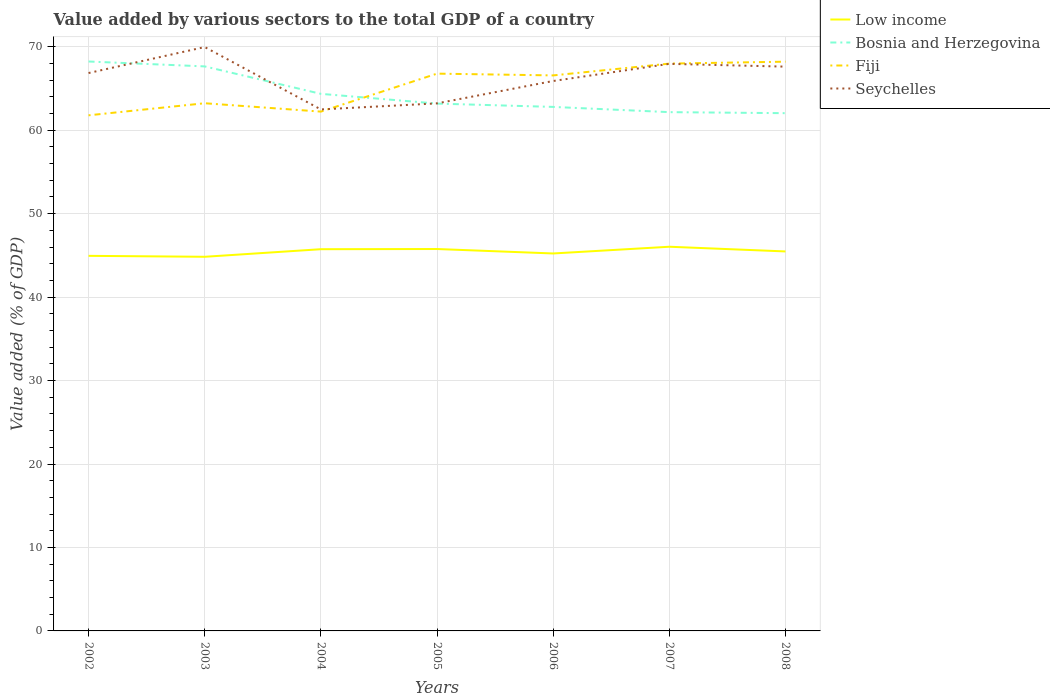How many different coloured lines are there?
Your answer should be very brief. 4. Is the number of lines equal to the number of legend labels?
Offer a very short reply. Yes. Across all years, what is the maximum value added by various sectors to the total GDP in Seychelles?
Make the answer very short. 62.49. In which year was the value added by various sectors to the total GDP in Fiji maximum?
Your answer should be very brief. 2002. What is the total value added by various sectors to the total GDP in Low income in the graph?
Ensure brevity in your answer.  0.53. What is the difference between the highest and the second highest value added by various sectors to the total GDP in Bosnia and Herzegovina?
Provide a succinct answer. 6.19. Is the value added by various sectors to the total GDP in Fiji strictly greater than the value added by various sectors to the total GDP in Low income over the years?
Provide a short and direct response. No. Does the graph contain any zero values?
Ensure brevity in your answer.  No. How many legend labels are there?
Your answer should be compact. 4. What is the title of the graph?
Your answer should be very brief. Value added by various sectors to the total GDP of a country. What is the label or title of the Y-axis?
Provide a succinct answer. Value added (% of GDP). What is the Value added (% of GDP) in Low income in 2002?
Give a very brief answer. 44.94. What is the Value added (% of GDP) in Bosnia and Herzegovina in 2002?
Your answer should be compact. 68.23. What is the Value added (% of GDP) in Fiji in 2002?
Your answer should be compact. 61.78. What is the Value added (% of GDP) in Seychelles in 2002?
Give a very brief answer. 66.85. What is the Value added (% of GDP) in Low income in 2003?
Your response must be concise. 44.83. What is the Value added (% of GDP) of Bosnia and Herzegovina in 2003?
Provide a short and direct response. 67.64. What is the Value added (% of GDP) of Fiji in 2003?
Offer a very short reply. 63.23. What is the Value added (% of GDP) of Seychelles in 2003?
Provide a succinct answer. 69.96. What is the Value added (% of GDP) in Low income in 2004?
Ensure brevity in your answer.  45.74. What is the Value added (% of GDP) of Bosnia and Herzegovina in 2004?
Ensure brevity in your answer.  64.35. What is the Value added (% of GDP) of Fiji in 2004?
Your answer should be compact. 62.23. What is the Value added (% of GDP) in Seychelles in 2004?
Offer a terse response. 62.49. What is the Value added (% of GDP) in Low income in 2005?
Offer a terse response. 45.76. What is the Value added (% of GDP) of Bosnia and Herzegovina in 2005?
Provide a succinct answer. 63.19. What is the Value added (% of GDP) of Fiji in 2005?
Offer a very short reply. 66.78. What is the Value added (% of GDP) in Seychelles in 2005?
Provide a short and direct response. 63.21. What is the Value added (% of GDP) of Low income in 2006?
Provide a succinct answer. 45.23. What is the Value added (% of GDP) of Bosnia and Herzegovina in 2006?
Make the answer very short. 62.79. What is the Value added (% of GDP) of Fiji in 2006?
Your answer should be very brief. 66.56. What is the Value added (% of GDP) in Seychelles in 2006?
Give a very brief answer. 65.89. What is the Value added (% of GDP) of Low income in 2007?
Offer a terse response. 46.03. What is the Value added (% of GDP) in Bosnia and Herzegovina in 2007?
Give a very brief answer. 62.16. What is the Value added (% of GDP) of Fiji in 2007?
Ensure brevity in your answer.  67.98. What is the Value added (% of GDP) in Seychelles in 2007?
Offer a terse response. 67.95. What is the Value added (% of GDP) of Low income in 2008?
Make the answer very short. 45.47. What is the Value added (% of GDP) of Bosnia and Herzegovina in 2008?
Keep it short and to the point. 62.04. What is the Value added (% of GDP) in Fiji in 2008?
Make the answer very short. 68.21. What is the Value added (% of GDP) in Seychelles in 2008?
Keep it short and to the point. 67.61. Across all years, what is the maximum Value added (% of GDP) in Low income?
Ensure brevity in your answer.  46.03. Across all years, what is the maximum Value added (% of GDP) in Bosnia and Herzegovina?
Your answer should be compact. 68.23. Across all years, what is the maximum Value added (% of GDP) in Fiji?
Your answer should be compact. 68.21. Across all years, what is the maximum Value added (% of GDP) of Seychelles?
Provide a succinct answer. 69.96. Across all years, what is the minimum Value added (% of GDP) in Low income?
Provide a succinct answer. 44.83. Across all years, what is the minimum Value added (% of GDP) in Bosnia and Herzegovina?
Offer a very short reply. 62.04. Across all years, what is the minimum Value added (% of GDP) in Fiji?
Offer a very short reply. 61.78. Across all years, what is the minimum Value added (% of GDP) of Seychelles?
Ensure brevity in your answer.  62.49. What is the total Value added (% of GDP) of Low income in the graph?
Your answer should be compact. 318. What is the total Value added (% of GDP) in Bosnia and Herzegovina in the graph?
Ensure brevity in your answer.  450.4. What is the total Value added (% of GDP) in Fiji in the graph?
Offer a very short reply. 456.76. What is the total Value added (% of GDP) in Seychelles in the graph?
Your response must be concise. 463.97. What is the difference between the Value added (% of GDP) in Low income in 2002 and that in 2003?
Offer a very short reply. 0.11. What is the difference between the Value added (% of GDP) in Bosnia and Herzegovina in 2002 and that in 2003?
Make the answer very short. 0.59. What is the difference between the Value added (% of GDP) in Fiji in 2002 and that in 2003?
Keep it short and to the point. -1.45. What is the difference between the Value added (% of GDP) in Seychelles in 2002 and that in 2003?
Offer a very short reply. -3.11. What is the difference between the Value added (% of GDP) in Low income in 2002 and that in 2004?
Provide a succinct answer. -0.8. What is the difference between the Value added (% of GDP) in Bosnia and Herzegovina in 2002 and that in 2004?
Provide a short and direct response. 3.88. What is the difference between the Value added (% of GDP) of Fiji in 2002 and that in 2004?
Your answer should be compact. -0.44. What is the difference between the Value added (% of GDP) in Seychelles in 2002 and that in 2004?
Give a very brief answer. 4.36. What is the difference between the Value added (% of GDP) in Low income in 2002 and that in 2005?
Provide a short and direct response. -0.82. What is the difference between the Value added (% of GDP) in Bosnia and Herzegovina in 2002 and that in 2005?
Provide a succinct answer. 5.04. What is the difference between the Value added (% of GDP) in Fiji in 2002 and that in 2005?
Your response must be concise. -4.99. What is the difference between the Value added (% of GDP) in Seychelles in 2002 and that in 2005?
Make the answer very short. 3.64. What is the difference between the Value added (% of GDP) in Low income in 2002 and that in 2006?
Your answer should be very brief. -0.29. What is the difference between the Value added (% of GDP) in Bosnia and Herzegovina in 2002 and that in 2006?
Give a very brief answer. 5.44. What is the difference between the Value added (% of GDP) of Fiji in 2002 and that in 2006?
Ensure brevity in your answer.  -4.78. What is the difference between the Value added (% of GDP) of Seychelles in 2002 and that in 2006?
Make the answer very short. 0.95. What is the difference between the Value added (% of GDP) of Low income in 2002 and that in 2007?
Your response must be concise. -1.09. What is the difference between the Value added (% of GDP) in Bosnia and Herzegovina in 2002 and that in 2007?
Provide a short and direct response. 6.07. What is the difference between the Value added (% of GDP) in Fiji in 2002 and that in 2007?
Ensure brevity in your answer.  -6.19. What is the difference between the Value added (% of GDP) of Seychelles in 2002 and that in 2007?
Provide a succinct answer. -1.1. What is the difference between the Value added (% of GDP) of Low income in 2002 and that in 2008?
Make the answer very short. -0.53. What is the difference between the Value added (% of GDP) in Bosnia and Herzegovina in 2002 and that in 2008?
Your answer should be compact. 6.19. What is the difference between the Value added (% of GDP) of Fiji in 2002 and that in 2008?
Provide a succinct answer. -6.43. What is the difference between the Value added (% of GDP) of Seychelles in 2002 and that in 2008?
Make the answer very short. -0.77. What is the difference between the Value added (% of GDP) of Low income in 2003 and that in 2004?
Make the answer very short. -0.91. What is the difference between the Value added (% of GDP) in Bosnia and Herzegovina in 2003 and that in 2004?
Your response must be concise. 3.29. What is the difference between the Value added (% of GDP) in Seychelles in 2003 and that in 2004?
Give a very brief answer. 7.47. What is the difference between the Value added (% of GDP) in Low income in 2003 and that in 2005?
Provide a short and direct response. -0.93. What is the difference between the Value added (% of GDP) in Bosnia and Herzegovina in 2003 and that in 2005?
Ensure brevity in your answer.  4.46. What is the difference between the Value added (% of GDP) in Fiji in 2003 and that in 2005?
Give a very brief answer. -3.55. What is the difference between the Value added (% of GDP) in Seychelles in 2003 and that in 2005?
Keep it short and to the point. 6.75. What is the difference between the Value added (% of GDP) in Low income in 2003 and that in 2006?
Offer a terse response. -0.4. What is the difference between the Value added (% of GDP) of Bosnia and Herzegovina in 2003 and that in 2006?
Your answer should be very brief. 4.85. What is the difference between the Value added (% of GDP) in Fiji in 2003 and that in 2006?
Your response must be concise. -3.34. What is the difference between the Value added (% of GDP) in Seychelles in 2003 and that in 2006?
Offer a terse response. 4.07. What is the difference between the Value added (% of GDP) of Low income in 2003 and that in 2007?
Your answer should be very brief. -1.2. What is the difference between the Value added (% of GDP) of Bosnia and Herzegovina in 2003 and that in 2007?
Provide a succinct answer. 5.48. What is the difference between the Value added (% of GDP) in Fiji in 2003 and that in 2007?
Offer a terse response. -4.75. What is the difference between the Value added (% of GDP) of Seychelles in 2003 and that in 2007?
Provide a succinct answer. 2.01. What is the difference between the Value added (% of GDP) in Low income in 2003 and that in 2008?
Your answer should be compact. -0.64. What is the difference between the Value added (% of GDP) of Bosnia and Herzegovina in 2003 and that in 2008?
Ensure brevity in your answer.  5.6. What is the difference between the Value added (% of GDP) of Fiji in 2003 and that in 2008?
Your answer should be very brief. -4.98. What is the difference between the Value added (% of GDP) of Seychelles in 2003 and that in 2008?
Your answer should be very brief. 2.35. What is the difference between the Value added (% of GDP) of Low income in 2004 and that in 2005?
Offer a terse response. -0.02. What is the difference between the Value added (% of GDP) in Bosnia and Herzegovina in 2004 and that in 2005?
Your response must be concise. 1.17. What is the difference between the Value added (% of GDP) of Fiji in 2004 and that in 2005?
Your response must be concise. -4.55. What is the difference between the Value added (% of GDP) of Seychelles in 2004 and that in 2005?
Make the answer very short. -0.73. What is the difference between the Value added (% of GDP) of Low income in 2004 and that in 2006?
Your answer should be compact. 0.51. What is the difference between the Value added (% of GDP) in Bosnia and Herzegovina in 2004 and that in 2006?
Keep it short and to the point. 1.57. What is the difference between the Value added (% of GDP) of Fiji in 2004 and that in 2006?
Provide a short and direct response. -4.34. What is the difference between the Value added (% of GDP) of Seychelles in 2004 and that in 2006?
Provide a short and direct response. -3.41. What is the difference between the Value added (% of GDP) of Low income in 2004 and that in 2007?
Your answer should be very brief. -0.3. What is the difference between the Value added (% of GDP) in Bosnia and Herzegovina in 2004 and that in 2007?
Provide a succinct answer. 2.19. What is the difference between the Value added (% of GDP) in Fiji in 2004 and that in 2007?
Provide a succinct answer. -5.75. What is the difference between the Value added (% of GDP) of Seychelles in 2004 and that in 2007?
Provide a succinct answer. -5.46. What is the difference between the Value added (% of GDP) in Low income in 2004 and that in 2008?
Provide a short and direct response. 0.27. What is the difference between the Value added (% of GDP) of Bosnia and Herzegovina in 2004 and that in 2008?
Your answer should be compact. 2.32. What is the difference between the Value added (% of GDP) in Fiji in 2004 and that in 2008?
Provide a succinct answer. -5.98. What is the difference between the Value added (% of GDP) in Seychelles in 2004 and that in 2008?
Offer a terse response. -5.13. What is the difference between the Value added (% of GDP) in Low income in 2005 and that in 2006?
Your answer should be compact. 0.53. What is the difference between the Value added (% of GDP) in Bosnia and Herzegovina in 2005 and that in 2006?
Offer a very short reply. 0.4. What is the difference between the Value added (% of GDP) of Fiji in 2005 and that in 2006?
Ensure brevity in your answer.  0.21. What is the difference between the Value added (% of GDP) in Seychelles in 2005 and that in 2006?
Provide a short and direct response. -2.68. What is the difference between the Value added (% of GDP) in Low income in 2005 and that in 2007?
Offer a terse response. -0.27. What is the difference between the Value added (% of GDP) of Bosnia and Herzegovina in 2005 and that in 2007?
Give a very brief answer. 1.02. What is the difference between the Value added (% of GDP) of Fiji in 2005 and that in 2007?
Your answer should be compact. -1.2. What is the difference between the Value added (% of GDP) in Seychelles in 2005 and that in 2007?
Your response must be concise. -4.74. What is the difference between the Value added (% of GDP) in Low income in 2005 and that in 2008?
Provide a short and direct response. 0.29. What is the difference between the Value added (% of GDP) in Bosnia and Herzegovina in 2005 and that in 2008?
Your answer should be very brief. 1.15. What is the difference between the Value added (% of GDP) of Fiji in 2005 and that in 2008?
Your answer should be compact. -1.43. What is the difference between the Value added (% of GDP) in Seychelles in 2005 and that in 2008?
Provide a short and direct response. -4.4. What is the difference between the Value added (% of GDP) of Low income in 2006 and that in 2007?
Offer a very short reply. -0.81. What is the difference between the Value added (% of GDP) in Bosnia and Herzegovina in 2006 and that in 2007?
Your response must be concise. 0.63. What is the difference between the Value added (% of GDP) of Fiji in 2006 and that in 2007?
Offer a very short reply. -1.41. What is the difference between the Value added (% of GDP) in Seychelles in 2006 and that in 2007?
Your answer should be very brief. -2.05. What is the difference between the Value added (% of GDP) in Low income in 2006 and that in 2008?
Your response must be concise. -0.24. What is the difference between the Value added (% of GDP) in Bosnia and Herzegovina in 2006 and that in 2008?
Make the answer very short. 0.75. What is the difference between the Value added (% of GDP) of Fiji in 2006 and that in 2008?
Give a very brief answer. -1.65. What is the difference between the Value added (% of GDP) in Seychelles in 2006 and that in 2008?
Provide a short and direct response. -1.72. What is the difference between the Value added (% of GDP) of Low income in 2007 and that in 2008?
Make the answer very short. 0.56. What is the difference between the Value added (% of GDP) of Bosnia and Herzegovina in 2007 and that in 2008?
Your answer should be compact. 0.12. What is the difference between the Value added (% of GDP) of Fiji in 2007 and that in 2008?
Your answer should be very brief. -0.23. What is the difference between the Value added (% of GDP) of Seychelles in 2007 and that in 2008?
Offer a terse response. 0.33. What is the difference between the Value added (% of GDP) of Low income in 2002 and the Value added (% of GDP) of Bosnia and Herzegovina in 2003?
Make the answer very short. -22.7. What is the difference between the Value added (% of GDP) in Low income in 2002 and the Value added (% of GDP) in Fiji in 2003?
Your answer should be very brief. -18.29. What is the difference between the Value added (% of GDP) of Low income in 2002 and the Value added (% of GDP) of Seychelles in 2003?
Your answer should be very brief. -25.02. What is the difference between the Value added (% of GDP) of Bosnia and Herzegovina in 2002 and the Value added (% of GDP) of Fiji in 2003?
Ensure brevity in your answer.  5. What is the difference between the Value added (% of GDP) of Bosnia and Herzegovina in 2002 and the Value added (% of GDP) of Seychelles in 2003?
Offer a very short reply. -1.73. What is the difference between the Value added (% of GDP) of Fiji in 2002 and the Value added (% of GDP) of Seychelles in 2003?
Keep it short and to the point. -8.18. What is the difference between the Value added (% of GDP) of Low income in 2002 and the Value added (% of GDP) of Bosnia and Herzegovina in 2004?
Offer a terse response. -19.41. What is the difference between the Value added (% of GDP) in Low income in 2002 and the Value added (% of GDP) in Fiji in 2004?
Provide a short and direct response. -17.28. What is the difference between the Value added (% of GDP) in Low income in 2002 and the Value added (% of GDP) in Seychelles in 2004?
Your answer should be compact. -17.54. What is the difference between the Value added (% of GDP) of Bosnia and Herzegovina in 2002 and the Value added (% of GDP) of Fiji in 2004?
Provide a succinct answer. 6. What is the difference between the Value added (% of GDP) in Bosnia and Herzegovina in 2002 and the Value added (% of GDP) in Seychelles in 2004?
Provide a short and direct response. 5.74. What is the difference between the Value added (% of GDP) of Fiji in 2002 and the Value added (% of GDP) of Seychelles in 2004?
Offer a terse response. -0.71. What is the difference between the Value added (% of GDP) of Low income in 2002 and the Value added (% of GDP) of Bosnia and Herzegovina in 2005?
Your response must be concise. -18.24. What is the difference between the Value added (% of GDP) in Low income in 2002 and the Value added (% of GDP) in Fiji in 2005?
Keep it short and to the point. -21.83. What is the difference between the Value added (% of GDP) in Low income in 2002 and the Value added (% of GDP) in Seychelles in 2005?
Make the answer very short. -18.27. What is the difference between the Value added (% of GDP) in Bosnia and Herzegovina in 2002 and the Value added (% of GDP) in Fiji in 2005?
Provide a succinct answer. 1.45. What is the difference between the Value added (% of GDP) in Bosnia and Herzegovina in 2002 and the Value added (% of GDP) in Seychelles in 2005?
Offer a terse response. 5.02. What is the difference between the Value added (% of GDP) in Fiji in 2002 and the Value added (% of GDP) in Seychelles in 2005?
Keep it short and to the point. -1.43. What is the difference between the Value added (% of GDP) in Low income in 2002 and the Value added (% of GDP) in Bosnia and Herzegovina in 2006?
Offer a terse response. -17.85. What is the difference between the Value added (% of GDP) in Low income in 2002 and the Value added (% of GDP) in Fiji in 2006?
Provide a succinct answer. -21.62. What is the difference between the Value added (% of GDP) in Low income in 2002 and the Value added (% of GDP) in Seychelles in 2006?
Your answer should be compact. -20.95. What is the difference between the Value added (% of GDP) of Bosnia and Herzegovina in 2002 and the Value added (% of GDP) of Fiji in 2006?
Your answer should be compact. 1.67. What is the difference between the Value added (% of GDP) in Bosnia and Herzegovina in 2002 and the Value added (% of GDP) in Seychelles in 2006?
Keep it short and to the point. 2.34. What is the difference between the Value added (% of GDP) in Fiji in 2002 and the Value added (% of GDP) in Seychelles in 2006?
Make the answer very short. -4.11. What is the difference between the Value added (% of GDP) of Low income in 2002 and the Value added (% of GDP) of Bosnia and Herzegovina in 2007?
Provide a succinct answer. -17.22. What is the difference between the Value added (% of GDP) of Low income in 2002 and the Value added (% of GDP) of Fiji in 2007?
Your response must be concise. -23.03. What is the difference between the Value added (% of GDP) of Low income in 2002 and the Value added (% of GDP) of Seychelles in 2007?
Your response must be concise. -23.01. What is the difference between the Value added (% of GDP) in Bosnia and Herzegovina in 2002 and the Value added (% of GDP) in Fiji in 2007?
Provide a short and direct response. 0.25. What is the difference between the Value added (% of GDP) in Bosnia and Herzegovina in 2002 and the Value added (% of GDP) in Seychelles in 2007?
Offer a very short reply. 0.28. What is the difference between the Value added (% of GDP) of Fiji in 2002 and the Value added (% of GDP) of Seychelles in 2007?
Your answer should be very brief. -6.17. What is the difference between the Value added (% of GDP) in Low income in 2002 and the Value added (% of GDP) in Bosnia and Herzegovina in 2008?
Your answer should be very brief. -17.1. What is the difference between the Value added (% of GDP) of Low income in 2002 and the Value added (% of GDP) of Fiji in 2008?
Provide a succinct answer. -23.27. What is the difference between the Value added (% of GDP) of Low income in 2002 and the Value added (% of GDP) of Seychelles in 2008?
Provide a short and direct response. -22.67. What is the difference between the Value added (% of GDP) of Bosnia and Herzegovina in 2002 and the Value added (% of GDP) of Fiji in 2008?
Offer a terse response. 0.02. What is the difference between the Value added (% of GDP) in Bosnia and Herzegovina in 2002 and the Value added (% of GDP) in Seychelles in 2008?
Ensure brevity in your answer.  0.62. What is the difference between the Value added (% of GDP) in Fiji in 2002 and the Value added (% of GDP) in Seychelles in 2008?
Give a very brief answer. -5.83. What is the difference between the Value added (% of GDP) of Low income in 2003 and the Value added (% of GDP) of Bosnia and Herzegovina in 2004?
Offer a very short reply. -19.52. What is the difference between the Value added (% of GDP) in Low income in 2003 and the Value added (% of GDP) in Fiji in 2004?
Offer a terse response. -17.39. What is the difference between the Value added (% of GDP) of Low income in 2003 and the Value added (% of GDP) of Seychelles in 2004?
Give a very brief answer. -17.66. What is the difference between the Value added (% of GDP) in Bosnia and Herzegovina in 2003 and the Value added (% of GDP) in Fiji in 2004?
Offer a very short reply. 5.42. What is the difference between the Value added (% of GDP) in Bosnia and Herzegovina in 2003 and the Value added (% of GDP) in Seychelles in 2004?
Provide a short and direct response. 5.16. What is the difference between the Value added (% of GDP) of Fiji in 2003 and the Value added (% of GDP) of Seychelles in 2004?
Your response must be concise. 0.74. What is the difference between the Value added (% of GDP) in Low income in 2003 and the Value added (% of GDP) in Bosnia and Herzegovina in 2005?
Make the answer very short. -18.36. What is the difference between the Value added (% of GDP) in Low income in 2003 and the Value added (% of GDP) in Fiji in 2005?
Provide a succinct answer. -21.95. What is the difference between the Value added (% of GDP) of Low income in 2003 and the Value added (% of GDP) of Seychelles in 2005?
Give a very brief answer. -18.38. What is the difference between the Value added (% of GDP) of Bosnia and Herzegovina in 2003 and the Value added (% of GDP) of Fiji in 2005?
Make the answer very short. 0.87. What is the difference between the Value added (% of GDP) of Bosnia and Herzegovina in 2003 and the Value added (% of GDP) of Seychelles in 2005?
Your answer should be very brief. 4.43. What is the difference between the Value added (% of GDP) in Fiji in 2003 and the Value added (% of GDP) in Seychelles in 2005?
Keep it short and to the point. 0.02. What is the difference between the Value added (% of GDP) in Low income in 2003 and the Value added (% of GDP) in Bosnia and Herzegovina in 2006?
Keep it short and to the point. -17.96. What is the difference between the Value added (% of GDP) in Low income in 2003 and the Value added (% of GDP) in Fiji in 2006?
Your response must be concise. -21.73. What is the difference between the Value added (% of GDP) in Low income in 2003 and the Value added (% of GDP) in Seychelles in 2006?
Make the answer very short. -21.06. What is the difference between the Value added (% of GDP) in Bosnia and Herzegovina in 2003 and the Value added (% of GDP) in Fiji in 2006?
Offer a terse response. 1.08. What is the difference between the Value added (% of GDP) in Bosnia and Herzegovina in 2003 and the Value added (% of GDP) in Seychelles in 2006?
Your response must be concise. 1.75. What is the difference between the Value added (% of GDP) in Fiji in 2003 and the Value added (% of GDP) in Seychelles in 2006?
Offer a terse response. -2.67. What is the difference between the Value added (% of GDP) in Low income in 2003 and the Value added (% of GDP) in Bosnia and Herzegovina in 2007?
Offer a terse response. -17.33. What is the difference between the Value added (% of GDP) in Low income in 2003 and the Value added (% of GDP) in Fiji in 2007?
Offer a very short reply. -23.15. What is the difference between the Value added (% of GDP) in Low income in 2003 and the Value added (% of GDP) in Seychelles in 2007?
Provide a succinct answer. -23.12. What is the difference between the Value added (% of GDP) of Bosnia and Herzegovina in 2003 and the Value added (% of GDP) of Fiji in 2007?
Offer a terse response. -0.33. What is the difference between the Value added (% of GDP) of Bosnia and Herzegovina in 2003 and the Value added (% of GDP) of Seychelles in 2007?
Give a very brief answer. -0.31. What is the difference between the Value added (% of GDP) in Fiji in 2003 and the Value added (% of GDP) in Seychelles in 2007?
Provide a succinct answer. -4.72. What is the difference between the Value added (% of GDP) in Low income in 2003 and the Value added (% of GDP) in Bosnia and Herzegovina in 2008?
Offer a very short reply. -17.21. What is the difference between the Value added (% of GDP) of Low income in 2003 and the Value added (% of GDP) of Fiji in 2008?
Keep it short and to the point. -23.38. What is the difference between the Value added (% of GDP) in Low income in 2003 and the Value added (% of GDP) in Seychelles in 2008?
Offer a very short reply. -22.78. What is the difference between the Value added (% of GDP) of Bosnia and Herzegovina in 2003 and the Value added (% of GDP) of Fiji in 2008?
Your answer should be very brief. -0.57. What is the difference between the Value added (% of GDP) in Bosnia and Herzegovina in 2003 and the Value added (% of GDP) in Seychelles in 2008?
Offer a terse response. 0.03. What is the difference between the Value added (% of GDP) in Fiji in 2003 and the Value added (% of GDP) in Seychelles in 2008?
Provide a succinct answer. -4.39. What is the difference between the Value added (% of GDP) of Low income in 2004 and the Value added (% of GDP) of Bosnia and Herzegovina in 2005?
Your answer should be compact. -17.45. What is the difference between the Value added (% of GDP) of Low income in 2004 and the Value added (% of GDP) of Fiji in 2005?
Give a very brief answer. -21.04. What is the difference between the Value added (% of GDP) in Low income in 2004 and the Value added (% of GDP) in Seychelles in 2005?
Ensure brevity in your answer.  -17.47. What is the difference between the Value added (% of GDP) of Bosnia and Herzegovina in 2004 and the Value added (% of GDP) of Fiji in 2005?
Ensure brevity in your answer.  -2.42. What is the difference between the Value added (% of GDP) of Bosnia and Herzegovina in 2004 and the Value added (% of GDP) of Seychelles in 2005?
Make the answer very short. 1.14. What is the difference between the Value added (% of GDP) in Fiji in 2004 and the Value added (% of GDP) in Seychelles in 2005?
Make the answer very short. -0.99. What is the difference between the Value added (% of GDP) in Low income in 2004 and the Value added (% of GDP) in Bosnia and Herzegovina in 2006?
Make the answer very short. -17.05. What is the difference between the Value added (% of GDP) of Low income in 2004 and the Value added (% of GDP) of Fiji in 2006?
Your response must be concise. -20.83. What is the difference between the Value added (% of GDP) in Low income in 2004 and the Value added (% of GDP) in Seychelles in 2006?
Offer a terse response. -20.16. What is the difference between the Value added (% of GDP) in Bosnia and Herzegovina in 2004 and the Value added (% of GDP) in Fiji in 2006?
Your answer should be very brief. -2.21. What is the difference between the Value added (% of GDP) in Bosnia and Herzegovina in 2004 and the Value added (% of GDP) in Seychelles in 2006?
Provide a succinct answer. -1.54. What is the difference between the Value added (% of GDP) of Fiji in 2004 and the Value added (% of GDP) of Seychelles in 2006?
Give a very brief answer. -3.67. What is the difference between the Value added (% of GDP) in Low income in 2004 and the Value added (% of GDP) in Bosnia and Herzegovina in 2007?
Provide a short and direct response. -16.42. What is the difference between the Value added (% of GDP) in Low income in 2004 and the Value added (% of GDP) in Fiji in 2007?
Provide a short and direct response. -22.24. What is the difference between the Value added (% of GDP) in Low income in 2004 and the Value added (% of GDP) in Seychelles in 2007?
Offer a terse response. -22.21. What is the difference between the Value added (% of GDP) in Bosnia and Herzegovina in 2004 and the Value added (% of GDP) in Fiji in 2007?
Provide a succinct answer. -3.62. What is the difference between the Value added (% of GDP) of Bosnia and Herzegovina in 2004 and the Value added (% of GDP) of Seychelles in 2007?
Your response must be concise. -3.59. What is the difference between the Value added (% of GDP) in Fiji in 2004 and the Value added (% of GDP) in Seychelles in 2007?
Give a very brief answer. -5.72. What is the difference between the Value added (% of GDP) in Low income in 2004 and the Value added (% of GDP) in Bosnia and Herzegovina in 2008?
Your answer should be very brief. -16.3. What is the difference between the Value added (% of GDP) in Low income in 2004 and the Value added (% of GDP) in Fiji in 2008?
Ensure brevity in your answer.  -22.47. What is the difference between the Value added (% of GDP) in Low income in 2004 and the Value added (% of GDP) in Seychelles in 2008?
Offer a terse response. -21.88. What is the difference between the Value added (% of GDP) in Bosnia and Herzegovina in 2004 and the Value added (% of GDP) in Fiji in 2008?
Provide a short and direct response. -3.85. What is the difference between the Value added (% of GDP) in Bosnia and Herzegovina in 2004 and the Value added (% of GDP) in Seychelles in 2008?
Your answer should be compact. -3.26. What is the difference between the Value added (% of GDP) in Fiji in 2004 and the Value added (% of GDP) in Seychelles in 2008?
Your answer should be compact. -5.39. What is the difference between the Value added (% of GDP) of Low income in 2005 and the Value added (% of GDP) of Bosnia and Herzegovina in 2006?
Provide a succinct answer. -17.03. What is the difference between the Value added (% of GDP) of Low income in 2005 and the Value added (% of GDP) of Fiji in 2006?
Keep it short and to the point. -20.8. What is the difference between the Value added (% of GDP) of Low income in 2005 and the Value added (% of GDP) of Seychelles in 2006?
Your response must be concise. -20.13. What is the difference between the Value added (% of GDP) in Bosnia and Herzegovina in 2005 and the Value added (% of GDP) in Fiji in 2006?
Ensure brevity in your answer.  -3.38. What is the difference between the Value added (% of GDP) of Bosnia and Herzegovina in 2005 and the Value added (% of GDP) of Seychelles in 2006?
Give a very brief answer. -2.71. What is the difference between the Value added (% of GDP) in Fiji in 2005 and the Value added (% of GDP) in Seychelles in 2006?
Keep it short and to the point. 0.88. What is the difference between the Value added (% of GDP) of Low income in 2005 and the Value added (% of GDP) of Bosnia and Herzegovina in 2007?
Your response must be concise. -16.4. What is the difference between the Value added (% of GDP) of Low income in 2005 and the Value added (% of GDP) of Fiji in 2007?
Your answer should be compact. -22.22. What is the difference between the Value added (% of GDP) in Low income in 2005 and the Value added (% of GDP) in Seychelles in 2007?
Give a very brief answer. -22.19. What is the difference between the Value added (% of GDP) in Bosnia and Herzegovina in 2005 and the Value added (% of GDP) in Fiji in 2007?
Keep it short and to the point. -4.79. What is the difference between the Value added (% of GDP) in Bosnia and Herzegovina in 2005 and the Value added (% of GDP) in Seychelles in 2007?
Your answer should be compact. -4.76. What is the difference between the Value added (% of GDP) of Fiji in 2005 and the Value added (% of GDP) of Seychelles in 2007?
Offer a terse response. -1.17. What is the difference between the Value added (% of GDP) of Low income in 2005 and the Value added (% of GDP) of Bosnia and Herzegovina in 2008?
Ensure brevity in your answer.  -16.28. What is the difference between the Value added (% of GDP) in Low income in 2005 and the Value added (% of GDP) in Fiji in 2008?
Keep it short and to the point. -22.45. What is the difference between the Value added (% of GDP) in Low income in 2005 and the Value added (% of GDP) in Seychelles in 2008?
Your answer should be very brief. -21.85. What is the difference between the Value added (% of GDP) of Bosnia and Herzegovina in 2005 and the Value added (% of GDP) of Fiji in 2008?
Provide a succinct answer. -5.02. What is the difference between the Value added (% of GDP) of Bosnia and Herzegovina in 2005 and the Value added (% of GDP) of Seychelles in 2008?
Make the answer very short. -4.43. What is the difference between the Value added (% of GDP) of Fiji in 2005 and the Value added (% of GDP) of Seychelles in 2008?
Your answer should be very brief. -0.84. What is the difference between the Value added (% of GDP) of Low income in 2006 and the Value added (% of GDP) of Bosnia and Herzegovina in 2007?
Keep it short and to the point. -16.93. What is the difference between the Value added (% of GDP) of Low income in 2006 and the Value added (% of GDP) of Fiji in 2007?
Your answer should be compact. -22.75. What is the difference between the Value added (% of GDP) of Low income in 2006 and the Value added (% of GDP) of Seychelles in 2007?
Offer a terse response. -22.72. What is the difference between the Value added (% of GDP) of Bosnia and Herzegovina in 2006 and the Value added (% of GDP) of Fiji in 2007?
Provide a short and direct response. -5.19. What is the difference between the Value added (% of GDP) in Bosnia and Herzegovina in 2006 and the Value added (% of GDP) in Seychelles in 2007?
Provide a short and direct response. -5.16. What is the difference between the Value added (% of GDP) in Fiji in 2006 and the Value added (% of GDP) in Seychelles in 2007?
Keep it short and to the point. -1.38. What is the difference between the Value added (% of GDP) of Low income in 2006 and the Value added (% of GDP) of Bosnia and Herzegovina in 2008?
Make the answer very short. -16.81. What is the difference between the Value added (% of GDP) in Low income in 2006 and the Value added (% of GDP) in Fiji in 2008?
Offer a very short reply. -22.98. What is the difference between the Value added (% of GDP) in Low income in 2006 and the Value added (% of GDP) in Seychelles in 2008?
Offer a terse response. -22.39. What is the difference between the Value added (% of GDP) of Bosnia and Herzegovina in 2006 and the Value added (% of GDP) of Fiji in 2008?
Make the answer very short. -5.42. What is the difference between the Value added (% of GDP) of Bosnia and Herzegovina in 2006 and the Value added (% of GDP) of Seychelles in 2008?
Ensure brevity in your answer.  -4.83. What is the difference between the Value added (% of GDP) of Fiji in 2006 and the Value added (% of GDP) of Seychelles in 2008?
Your response must be concise. -1.05. What is the difference between the Value added (% of GDP) of Low income in 2007 and the Value added (% of GDP) of Bosnia and Herzegovina in 2008?
Your answer should be compact. -16. What is the difference between the Value added (% of GDP) of Low income in 2007 and the Value added (% of GDP) of Fiji in 2008?
Provide a succinct answer. -22.18. What is the difference between the Value added (% of GDP) of Low income in 2007 and the Value added (% of GDP) of Seychelles in 2008?
Ensure brevity in your answer.  -21.58. What is the difference between the Value added (% of GDP) in Bosnia and Herzegovina in 2007 and the Value added (% of GDP) in Fiji in 2008?
Your response must be concise. -6.05. What is the difference between the Value added (% of GDP) of Bosnia and Herzegovina in 2007 and the Value added (% of GDP) of Seychelles in 2008?
Provide a succinct answer. -5.45. What is the difference between the Value added (% of GDP) of Fiji in 2007 and the Value added (% of GDP) of Seychelles in 2008?
Provide a succinct answer. 0.36. What is the average Value added (% of GDP) in Low income per year?
Your answer should be very brief. 45.43. What is the average Value added (% of GDP) in Bosnia and Herzegovina per year?
Provide a succinct answer. 64.34. What is the average Value added (% of GDP) of Fiji per year?
Offer a terse response. 65.25. What is the average Value added (% of GDP) of Seychelles per year?
Your response must be concise. 66.28. In the year 2002, what is the difference between the Value added (% of GDP) in Low income and Value added (% of GDP) in Bosnia and Herzegovina?
Your answer should be very brief. -23.29. In the year 2002, what is the difference between the Value added (% of GDP) of Low income and Value added (% of GDP) of Fiji?
Offer a very short reply. -16.84. In the year 2002, what is the difference between the Value added (% of GDP) in Low income and Value added (% of GDP) in Seychelles?
Your answer should be very brief. -21.91. In the year 2002, what is the difference between the Value added (% of GDP) in Bosnia and Herzegovina and Value added (% of GDP) in Fiji?
Offer a very short reply. 6.45. In the year 2002, what is the difference between the Value added (% of GDP) in Bosnia and Herzegovina and Value added (% of GDP) in Seychelles?
Make the answer very short. 1.38. In the year 2002, what is the difference between the Value added (% of GDP) in Fiji and Value added (% of GDP) in Seychelles?
Offer a very short reply. -5.07. In the year 2003, what is the difference between the Value added (% of GDP) in Low income and Value added (% of GDP) in Bosnia and Herzegovina?
Provide a short and direct response. -22.81. In the year 2003, what is the difference between the Value added (% of GDP) of Low income and Value added (% of GDP) of Fiji?
Your answer should be very brief. -18.4. In the year 2003, what is the difference between the Value added (% of GDP) of Low income and Value added (% of GDP) of Seychelles?
Give a very brief answer. -25.13. In the year 2003, what is the difference between the Value added (% of GDP) of Bosnia and Herzegovina and Value added (% of GDP) of Fiji?
Keep it short and to the point. 4.41. In the year 2003, what is the difference between the Value added (% of GDP) in Bosnia and Herzegovina and Value added (% of GDP) in Seychelles?
Offer a terse response. -2.32. In the year 2003, what is the difference between the Value added (% of GDP) of Fiji and Value added (% of GDP) of Seychelles?
Make the answer very short. -6.73. In the year 2004, what is the difference between the Value added (% of GDP) in Low income and Value added (% of GDP) in Bosnia and Herzegovina?
Offer a terse response. -18.62. In the year 2004, what is the difference between the Value added (% of GDP) of Low income and Value added (% of GDP) of Fiji?
Keep it short and to the point. -16.49. In the year 2004, what is the difference between the Value added (% of GDP) of Low income and Value added (% of GDP) of Seychelles?
Your answer should be very brief. -16.75. In the year 2004, what is the difference between the Value added (% of GDP) of Bosnia and Herzegovina and Value added (% of GDP) of Fiji?
Keep it short and to the point. 2.13. In the year 2004, what is the difference between the Value added (% of GDP) in Bosnia and Herzegovina and Value added (% of GDP) in Seychelles?
Your response must be concise. 1.87. In the year 2004, what is the difference between the Value added (% of GDP) of Fiji and Value added (% of GDP) of Seychelles?
Keep it short and to the point. -0.26. In the year 2005, what is the difference between the Value added (% of GDP) in Low income and Value added (% of GDP) in Bosnia and Herzegovina?
Offer a terse response. -17.43. In the year 2005, what is the difference between the Value added (% of GDP) in Low income and Value added (% of GDP) in Fiji?
Give a very brief answer. -21.02. In the year 2005, what is the difference between the Value added (% of GDP) of Low income and Value added (% of GDP) of Seychelles?
Your answer should be very brief. -17.45. In the year 2005, what is the difference between the Value added (% of GDP) of Bosnia and Herzegovina and Value added (% of GDP) of Fiji?
Your response must be concise. -3.59. In the year 2005, what is the difference between the Value added (% of GDP) in Bosnia and Herzegovina and Value added (% of GDP) in Seychelles?
Your response must be concise. -0.03. In the year 2005, what is the difference between the Value added (% of GDP) of Fiji and Value added (% of GDP) of Seychelles?
Keep it short and to the point. 3.56. In the year 2006, what is the difference between the Value added (% of GDP) in Low income and Value added (% of GDP) in Bosnia and Herzegovina?
Your answer should be compact. -17.56. In the year 2006, what is the difference between the Value added (% of GDP) in Low income and Value added (% of GDP) in Fiji?
Offer a very short reply. -21.34. In the year 2006, what is the difference between the Value added (% of GDP) in Low income and Value added (% of GDP) in Seychelles?
Keep it short and to the point. -20.67. In the year 2006, what is the difference between the Value added (% of GDP) of Bosnia and Herzegovina and Value added (% of GDP) of Fiji?
Your answer should be very brief. -3.78. In the year 2006, what is the difference between the Value added (% of GDP) in Bosnia and Herzegovina and Value added (% of GDP) in Seychelles?
Provide a short and direct response. -3.11. In the year 2006, what is the difference between the Value added (% of GDP) of Fiji and Value added (% of GDP) of Seychelles?
Provide a short and direct response. 0.67. In the year 2007, what is the difference between the Value added (% of GDP) in Low income and Value added (% of GDP) in Bosnia and Herzegovina?
Keep it short and to the point. -16.13. In the year 2007, what is the difference between the Value added (% of GDP) in Low income and Value added (% of GDP) in Fiji?
Your answer should be very brief. -21.94. In the year 2007, what is the difference between the Value added (% of GDP) in Low income and Value added (% of GDP) in Seychelles?
Make the answer very short. -21.91. In the year 2007, what is the difference between the Value added (% of GDP) of Bosnia and Herzegovina and Value added (% of GDP) of Fiji?
Make the answer very short. -5.81. In the year 2007, what is the difference between the Value added (% of GDP) in Bosnia and Herzegovina and Value added (% of GDP) in Seychelles?
Offer a terse response. -5.79. In the year 2007, what is the difference between the Value added (% of GDP) in Fiji and Value added (% of GDP) in Seychelles?
Offer a very short reply. 0.03. In the year 2008, what is the difference between the Value added (% of GDP) of Low income and Value added (% of GDP) of Bosnia and Herzegovina?
Your answer should be compact. -16.57. In the year 2008, what is the difference between the Value added (% of GDP) in Low income and Value added (% of GDP) in Fiji?
Provide a succinct answer. -22.74. In the year 2008, what is the difference between the Value added (% of GDP) of Low income and Value added (% of GDP) of Seychelles?
Your response must be concise. -22.14. In the year 2008, what is the difference between the Value added (% of GDP) of Bosnia and Herzegovina and Value added (% of GDP) of Fiji?
Offer a very short reply. -6.17. In the year 2008, what is the difference between the Value added (% of GDP) of Bosnia and Herzegovina and Value added (% of GDP) of Seychelles?
Your answer should be very brief. -5.58. In the year 2008, what is the difference between the Value added (% of GDP) in Fiji and Value added (% of GDP) in Seychelles?
Your answer should be compact. 0.59. What is the ratio of the Value added (% of GDP) in Low income in 2002 to that in 2003?
Ensure brevity in your answer.  1. What is the ratio of the Value added (% of GDP) in Bosnia and Herzegovina in 2002 to that in 2003?
Offer a terse response. 1.01. What is the ratio of the Value added (% of GDP) in Fiji in 2002 to that in 2003?
Ensure brevity in your answer.  0.98. What is the ratio of the Value added (% of GDP) of Seychelles in 2002 to that in 2003?
Your answer should be very brief. 0.96. What is the ratio of the Value added (% of GDP) of Low income in 2002 to that in 2004?
Offer a very short reply. 0.98. What is the ratio of the Value added (% of GDP) of Bosnia and Herzegovina in 2002 to that in 2004?
Keep it short and to the point. 1.06. What is the ratio of the Value added (% of GDP) of Seychelles in 2002 to that in 2004?
Ensure brevity in your answer.  1.07. What is the ratio of the Value added (% of GDP) in Low income in 2002 to that in 2005?
Offer a terse response. 0.98. What is the ratio of the Value added (% of GDP) in Bosnia and Herzegovina in 2002 to that in 2005?
Provide a succinct answer. 1.08. What is the ratio of the Value added (% of GDP) in Fiji in 2002 to that in 2005?
Your answer should be very brief. 0.93. What is the ratio of the Value added (% of GDP) in Seychelles in 2002 to that in 2005?
Your answer should be compact. 1.06. What is the ratio of the Value added (% of GDP) of Low income in 2002 to that in 2006?
Offer a terse response. 0.99. What is the ratio of the Value added (% of GDP) in Bosnia and Herzegovina in 2002 to that in 2006?
Offer a terse response. 1.09. What is the ratio of the Value added (% of GDP) in Fiji in 2002 to that in 2006?
Your response must be concise. 0.93. What is the ratio of the Value added (% of GDP) in Seychelles in 2002 to that in 2006?
Offer a terse response. 1.01. What is the ratio of the Value added (% of GDP) in Low income in 2002 to that in 2007?
Provide a succinct answer. 0.98. What is the ratio of the Value added (% of GDP) in Bosnia and Herzegovina in 2002 to that in 2007?
Provide a short and direct response. 1.1. What is the ratio of the Value added (% of GDP) in Fiji in 2002 to that in 2007?
Make the answer very short. 0.91. What is the ratio of the Value added (% of GDP) of Seychelles in 2002 to that in 2007?
Keep it short and to the point. 0.98. What is the ratio of the Value added (% of GDP) in Low income in 2002 to that in 2008?
Provide a short and direct response. 0.99. What is the ratio of the Value added (% of GDP) in Bosnia and Herzegovina in 2002 to that in 2008?
Offer a very short reply. 1.1. What is the ratio of the Value added (% of GDP) in Fiji in 2002 to that in 2008?
Keep it short and to the point. 0.91. What is the ratio of the Value added (% of GDP) in Seychelles in 2002 to that in 2008?
Make the answer very short. 0.99. What is the ratio of the Value added (% of GDP) of Low income in 2003 to that in 2004?
Offer a terse response. 0.98. What is the ratio of the Value added (% of GDP) in Bosnia and Herzegovina in 2003 to that in 2004?
Give a very brief answer. 1.05. What is the ratio of the Value added (% of GDP) in Fiji in 2003 to that in 2004?
Provide a short and direct response. 1.02. What is the ratio of the Value added (% of GDP) in Seychelles in 2003 to that in 2004?
Your answer should be compact. 1.12. What is the ratio of the Value added (% of GDP) of Low income in 2003 to that in 2005?
Your response must be concise. 0.98. What is the ratio of the Value added (% of GDP) of Bosnia and Herzegovina in 2003 to that in 2005?
Your answer should be very brief. 1.07. What is the ratio of the Value added (% of GDP) in Fiji in 2003 to that in 2005?
Your response must be concise. 0.95. What is the ratio of the Value added (% of GDP) in Seychelles in 2003 to that in 2005?
Offer a terse response. 1.11. What is the ratio of the Value added (% of GDP) in Bosnia and Herzegovina in 2003 to that in 2006?
Provide a succinct answer. 1.08. What is the ratio of the Value added (% of GDP) in Fiji in 2003 to that in 2006?
Provide a short and direct response. 0.95. What is the ratio of the Value added (% of GDP) in Seychelles in 2003 to that in 2006?
Ensure brevity in your answer.  1.06. What is the ratio of the Value added (% of GDP) of Low income in 2003 to that in 2007?
Your answer should be very brief. 0.97. What is the ratio of the Value added (% of GDP) in Bosnia and Herzegovina in 2003 to that in 2007?
Keep it short and to the point. 1.09. What is the ratio of the Value added (% of GDP) of Fiji in 2003 to that in 2007?
Your answer should be very brief. 0.93. What is the ratio of the Value added (% of GDP) of Seychelles in 2003 to that in 2007?
Your answer should be very brief. 1.03. What is the ratio of the Value added (% of GDP) of Low income in 2003 to that in 2008?
Provide a succinct answer. 0.99. What is the ratio of the Value added (% of GDP) of Bosnia and Herzegovina in 2003 to that in 2008?
Provide a succinct answer. 1.09. What is the ratio of the Value added (% of GDP) of Fiji in 2003 to that in 2008?
Offer a terse response. 0.93. What is the ratio of the Value added (% of GDP) of Seychelles in 2003 to that in 2008?
Your answer should be very brief. 1.03. What is the ratio of the Value added (% of GDP) of Low income in 2004 to that in 2005?
Ensure brevity in your answer.  1. What is the ratio of the Value added (% of GDP) of Bosnia and Herzegovina in 2004 to that in 2005?
Provide a succinct answer. 1.02. What is the ratio of the Value added (% of GDP) in Fiji in 2004 to that in 2005?
Your answer should be compact. 0.93. What is the ratio of the Value added (% of GDP) in Low income in 2004 to that in 2006?
Make the answer very short. 1.01. What is the ratio of the Value added (% of GDP) of Bosnia and Herzegovina in 2004 to that in 2006?
Make the answer very short. 1.02. What is the ratio of the Value added (% of GDP) of Fiji in 2004 to that in 2006?
Your answer should be very brief. 0.93. What is the ratio of the Value added (% of GDP) in Seychelles in 2004 to that in 2006?
Your answer should be compact. 0.95. What is the ratio of the Value added (% of GDP) of Low income in 2004 to that in 2007?
Give a very brief answer. 0.99. What is the ratio of the Value added (% of GDP) of Bosnia and Herzegovina in 2004 to that in 2007?
Your response must be concise. 1.04. What is the ratio of the Value added (% of GDP) of Fiji in 2004 to that in 2007?
Offer a terse response. 0.92. What is the ratio of the Value added (% of GDP) of Seychelles in 2004 to that in 2007?
Your answer should be very brief. 0.92. What is the ratio of the Value added (% of GDP) in Low income in 2004 to that in 2008?
Offer a terse response. 1.01. What is the ratio of the Value added (% of GDP) in Bosnia and Herzegovina in 2004 to that in 2008?
Your answer should be compact. 1.04. What is the ratio of the Value added (% of GDP) in Fiji in 2004 to that in 2008?
Your response must be concise. 0.91. What is the ratio of the Value added (% of GDP) in Seychelles in 2004 to that in 2008?
Your answer should be very brief. 0.92. What is the ratio of the Value added (% of GDP) in Low income in 2005 to that in 2006?
Give a very brief answer. 1.01. What is the ratio of the Value added (% of GDP) of Fiji in 2005 to that in 2006?
Your response must be concise. 1. What is the ratio of the Value added (% of GDP) in Seychelles in 2005 to that in 2006?
Ensure brevity in your answer.  0.96. What is the ratio of the Value added (% of GDP) in Low income in 2005 to that in 2007?
Offer a very short reply. 0.99. What is the ratio of the Value added (% of GDP) of Bosnia and Herzegovina in 2005 to that in 2007?
Provide a short and direct response. 1.02. What is the ratio of the Value added (% of GDP) in Fiji in 2005 to that in 2007?
Provide a succinct answer. 0.98. What is the ratio of the Value added (% of GDP) in Seychelles in 2005 to that in 2007?
Your response must be concise. 0.93. What is the ratio of the Value added (% of GDP) in Low income in 2005 to that in 2008?
Provide a succinct answer. 1.01. What is the ratio of the Value added (% of GDP) in Bosnia and Herzegovina in 2005 to that in 2008?
Provide a succinct answer. 1.02. What is the ratio of the Value added (% of GDP) of Seychelles in 2005 to that in 2008?
Provide a short and direct response. 0.93. What is the ratio of the Value added (% of GDP) in Low income in 2006 to that in 2007?
Offer a very short reply. 0.98. What is the ratio of the Value added (% of GDP) in Bosnia and Herzegovina in 2006 to that in 2007?
Ensure brevity in your answer.  1.01. What is the ratio of the Value added (% of GDP) in Fiji in 2006 to that in 2007?
Make the answer very short. 0.98. What is the ratio of the Value added (% of GDP) in Seychelles in 2006 to that in 2007?
Your response must be concise. 0.97. What is the ratio of the Value added (% of GDP) of Bosnia and Herzegovina in 2006 to that in 2008?
Ensure brevity in your answer.  1.01. What is the ratio of the Value added (% of GDP) of Fiji in 2006 to that in 2008?
Keep it short and to the point. 0.98. What is the ratio of the Value added (% of GDP) of Seychelles in 2006 to that in 2008?
Ensure brevity in your answer.  0.97. What is the ratio of the Value added (% of GDP) of Low income in 2007 to that in 2008?
Ensure brevity in your answer.  1.01. What is the difference between the highest and the second highest Value added (% of GDP) of Low income?
Make the answer very short. 0.27. What is the difference between the highest and the second highest Value added (% of GDP) in Bosnia and Herzegovina?
Your response must be concise. 0.59. What is the difference between the highest and the second highest Value added (% of GDP) in Fiji?
Ensure brevity in your answer.  0.23. What is the difference between the highest and the second highest Value added (% of GDP) in Seychelles?
Give a very brief answer. 2.01. What is the difference between the highest and the lowest Value added (% of GDP) of Low income?
Keep it short and to the point. 1.2. What is the difference between the highest and the lowest Value added (% of GDP) in Bosnia and Herzegovina?
Offer a very short reply. 6.19. What is the difference between the highest and the lowest Value added (% of GDP) of Fiji?
Make the answer very short. 6.43. What is the difference between the highest and the lowest Value added (% of GDP) of Seychelles?
Your answer should be compact. 7.47. 